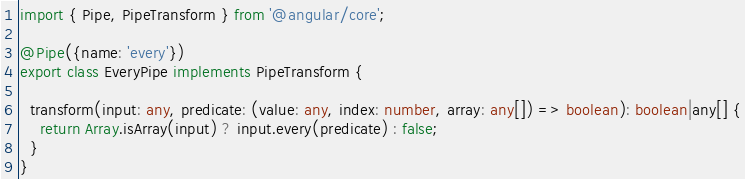Convert code to text. <code><loc_0><loc_0><loc_500><loc_500><_TypeScript_>import { Pipe, PipeTransform } from '@angular/core';

@Pipe({name: 'every'})
export class EveryPipe implements PipeTransform {

  transform(input: any, predicate: (value: any, index: number, array: any[]) => boolean): boolean|any[] {
    return Array.isArray(input) ? input.every(predicate) : false;
  }
}
</code> 